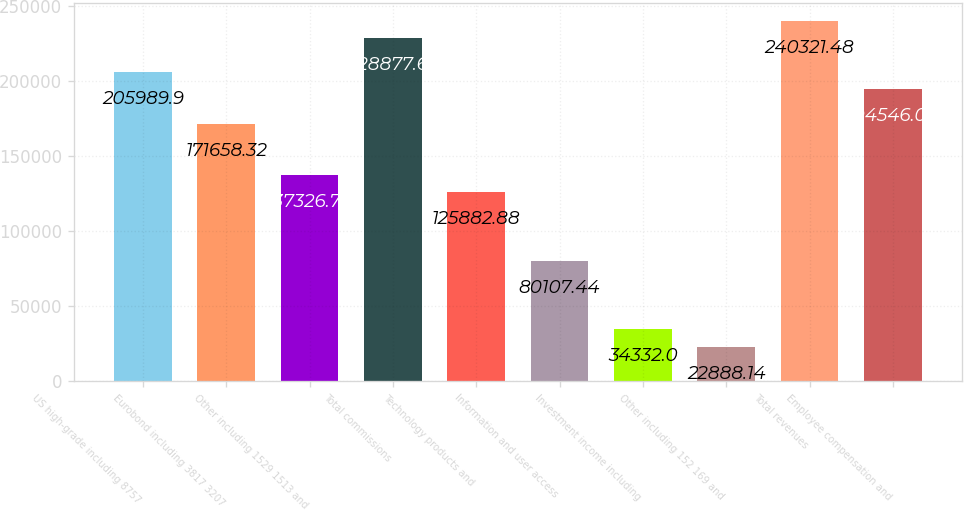<chart> <loc_0><loc_0><loc_500><loc_500><bar_chart><fcel>US high-grade including 8757<fcel>Eurobond including 3817 3207<fcel>Other including 1529 1513 and<fcel>Total commissions<fcel>Technology products and<fcel>Information and user access<fcel>Investment income including<fcel>Other including 152 169 and<fcel>Total revenues<fcel>Employee compensation and<nl><fcel>205990<fcel>171658<fcel>137327<fcel>228878<fcel>125883<fcel>80107.4<fcel>34332<fcel>22888.1<fcel>240321<fcel>194546<nl></chart> 